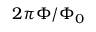Convert formula to latex. <formula><loc_0><loc_0><loc_500><loc_500>2 \pi \Phi / \Phi _ { 0 }</formula> 